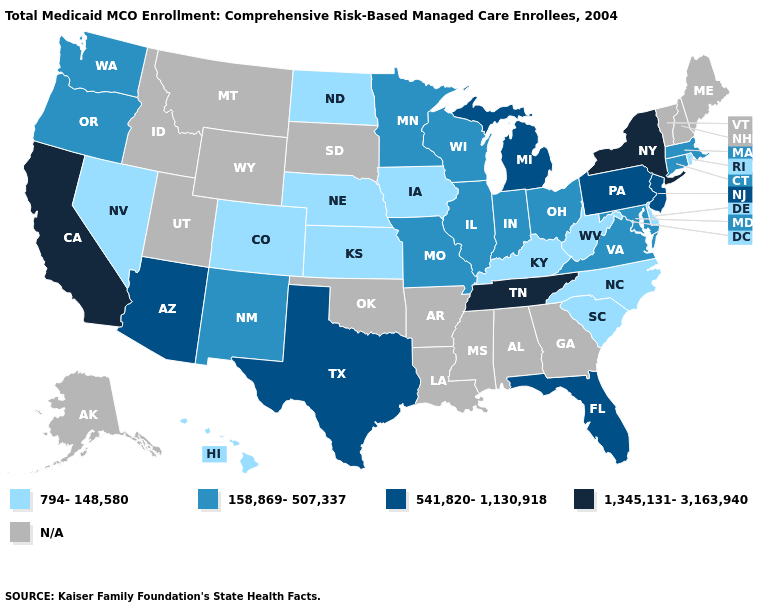What is the lowest value in the MidWest?
Short answer required. 794-148,580. What is the value of West Virginia?
Quick response, please. 794-148,580. Among the states that border Idaho , which have the lowest value?
Give a very brief answer. Nevada. What is the value of Illinois?
Short answer required. 158,869-507,337. Which states have the highest value in the USA?
Give a very brief answer. California, New York, Tennessee. Which states have the lowest value in the West?
Be succinct. Colorado, Hawaii, Nevada. What is the lowest value in the MidWest?
Concise answer only. 794-148,580. What is the highest value in the South ?
Write a very short answer. 1,345,131-3,163,940. Which states have the lowest value in the USA?
Be succinct. Colorado, Delaware, Hawaii, Iowa, Kansas, Kentucky, Nebraska, Nevada, North Carolina, North Dakota, Rhode Island, South Carolina, West Virginia. Among the states that border Tennessee , which have the lowest value?
Keep it brief. Kentucky, North Carolina. What is the value of Wisconsin?
Quick response, please. 158,869-507,337. Among the states that border Georgia , does North Carolina have the highest value?
Keep it brief. No. 